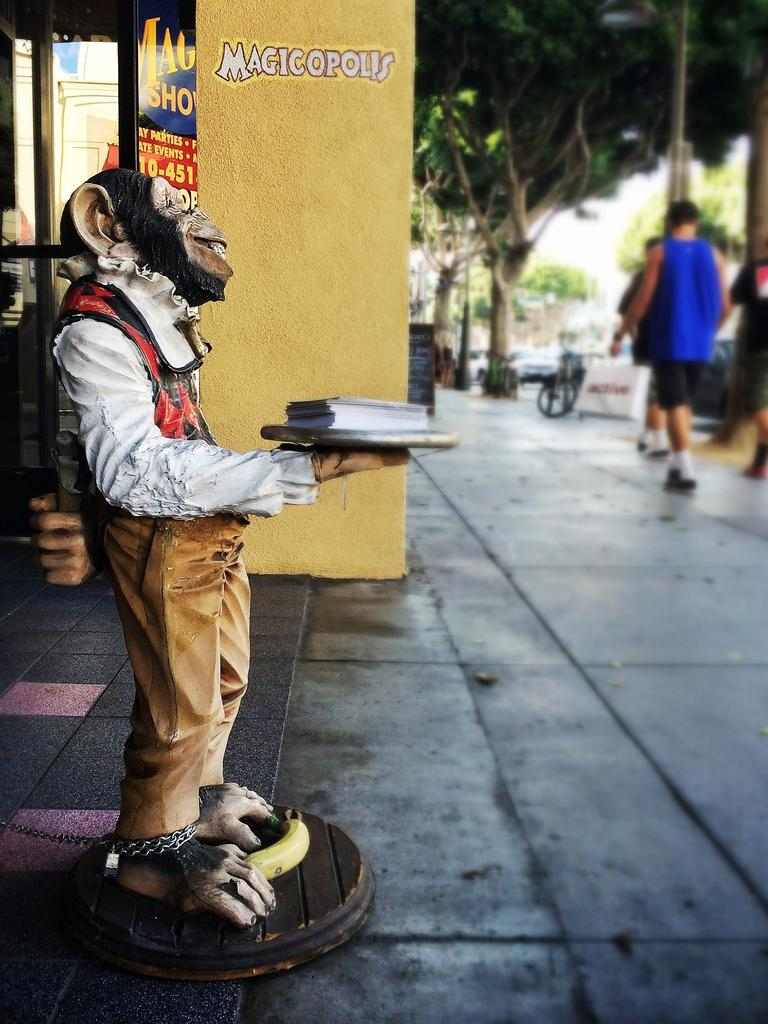What is the main subject of the image? The main subject of the image is a statue of a monkey. What is the monkey statue holding? The monkey statue is holding a plate. What is on the plate that the monkey statue is holding? There is a book on the plate. What type of establishment can be seen in the image? There is a shop in the image. What type of natural elements are present in the image? There are trees in the image. How many people are visible in the image? There are three persons standing in the image. What type of transportation is present in the image? There are vehicles in the image. What type of behavior is the monkey exhibiting in the image? The monkey is a statue and does not exhibit any behavior in the image. What event is taking place in the image? There is no specific event taking place in the image; it is a general scene featuring a statue, a shop, trees, people, and vehicles. 